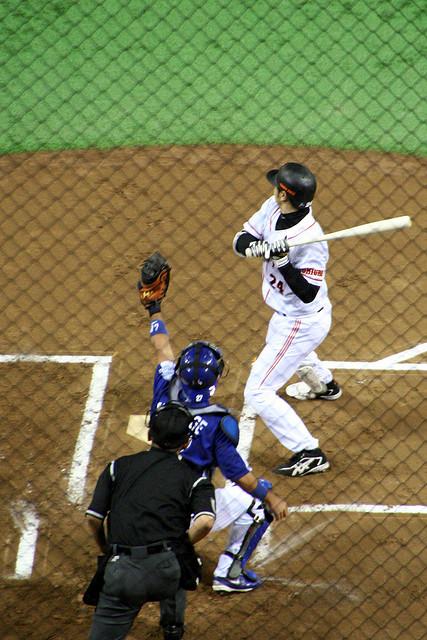What is each man called?
Be succinct. Batter, catcher, umpire. What are the people doing?
Concise answer only. Playing baseball. Have you ever watched a match like that?
Quick response, please. Yes. 